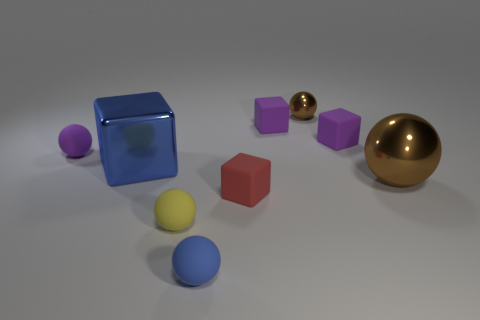What size is the purple thing that is the same shape as the tiny blue object?
Your answer should be very brief. Small. What number of spheres are both in front of the purple sphere and left of the small brown shiny object?
Keep it short and to the point. 2. Is the shape of the red thing the same as the metal thing that is in front of the large blue metal block?
Keep it short and to the point. No. Are there more tiny matte things that are behind the big brown thing than large shiny objects?
Provide a short and direct response. Yes. Is the number of small red matte blocks in front of the small blue ball less than the number of small cyan metallic cylinders?
Ensure brevity in your answer.  No. What number of small matte spheres have the same color as the large metallic ball?
Give a very brief answer. 0. There is a tiny ball that is behind the large brown thing and on the right side of the yellow rubber object; what is its material?
Provide a short and direct response. Metal. Is the color of the small cube that is in front of the purple rubber sphere the same as the big shiny thing on the right side of the red matte thing?
Your answer should be very brief. No. How many red objects are matte spheres or tiny objects?
Offer a terse response. 1. Is the number of tiny purple balls right of the red matte block less than the number of yellow things to the left of the purple sphere?
Provide a short and direct response. No. 